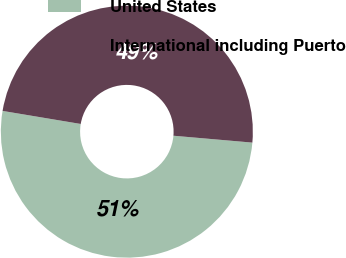<chart> <loc_0><loc_0><loc_500><loc_500><pie_chart><fcel>United States<fcel>International including Puerto<nl><fcel>51.25%<fcel>48.75%<nl></chart> 